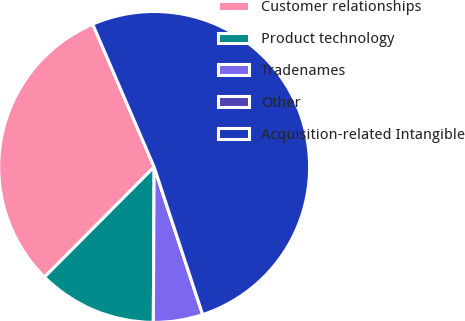Convert chart to OTSL. <chart><loc_0><loc_0><loc_500><loc_500><pie_chart><fcel>Customer relationships<fcel>Product technology<fcel>Tradenames<fcel>Other<fcel>Acquisition-related Intangible<nl><fcel>31.07%<fcel>12.38%<fcel>5.14%<fcel>0.0%<fcel>51.41%<nl></chart> 